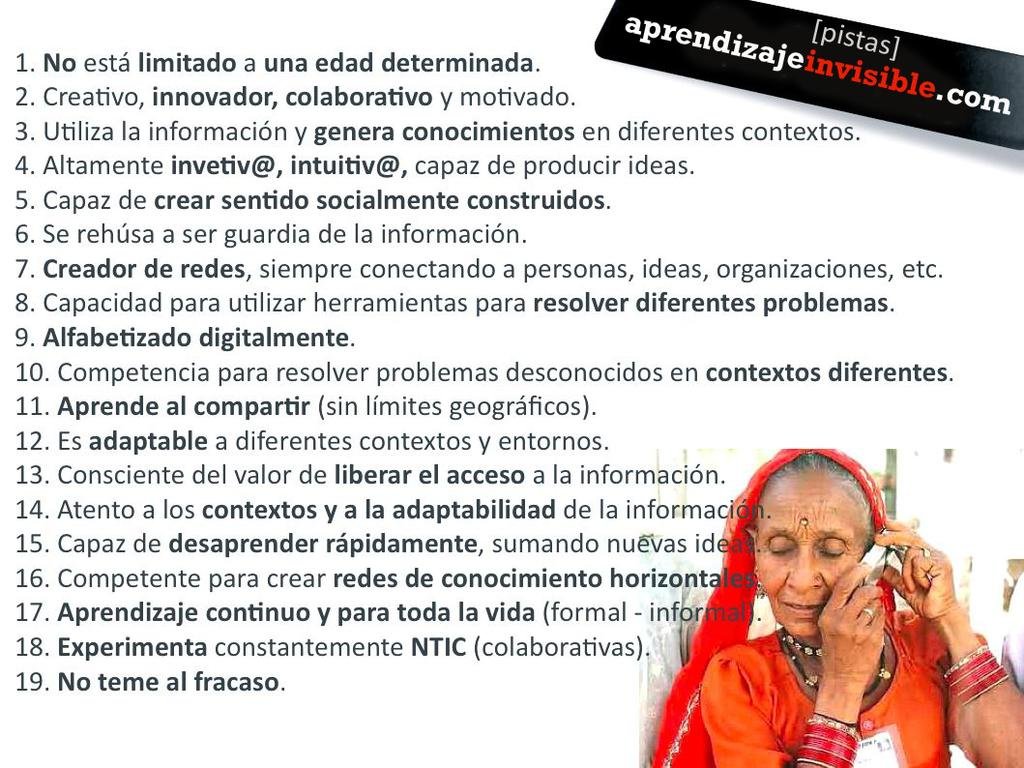What is the main subject of the image? The main subject of the image is a woman. What is the woman holding in her hands? The woman is holding an object in her hands. What type of jewelry is the woman wearing? The woman is wearing bangles. Are there any other objects visible on the woman? Yes, there are other objects visible on the woman. What can be seen in addition to the woman and the objects she is wearing or holding? There is text or writing present in the image. How many frogs are sitting on the woman's head in the image? There are no frogs present in the image, so it is not possible to determine how many would be sitting on the woman's head. 